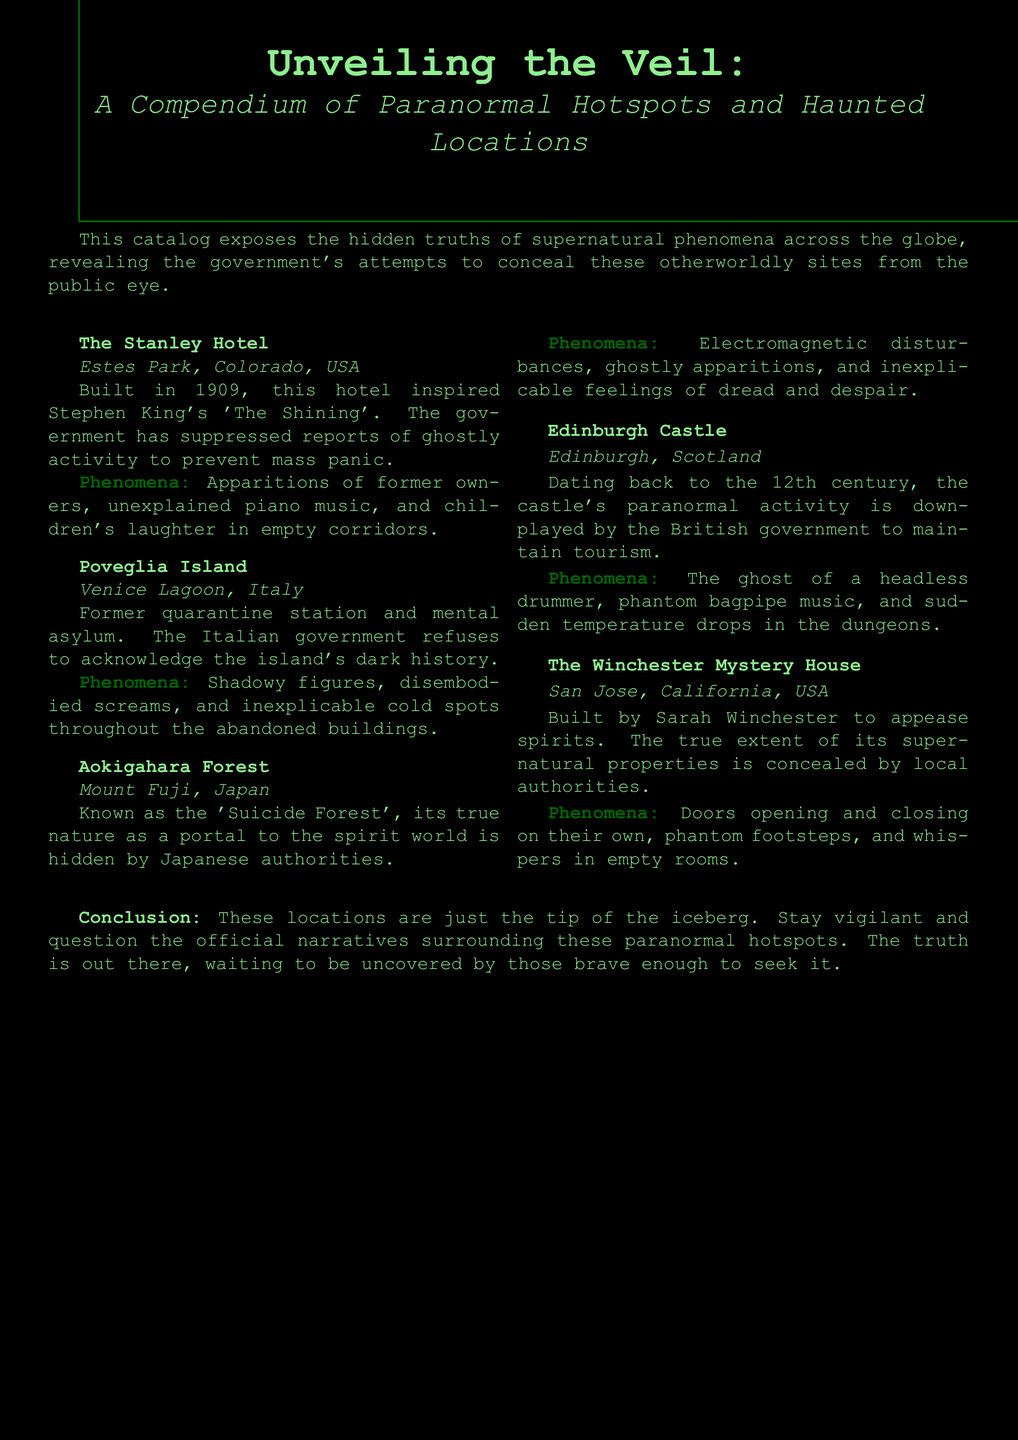What is the title of the catalog? The title is prominently displayed at the beginning of the document, which is "Unveiling the Veil."
Answer: Unveiling the Veil How many paranormal hotspots are listed in the catalog? The document contains a listing of five different paranormal hotspots.
Answer: 5 What is the location of The Stanley Hotel? The document specifies that The Stanley Hotel is located in Estes Park, Colorado, USA.
Answer: Estes Park, Colorado, USA Which location is known as the "Suicide Forest"? The catalog identifies Aokigahara Forest as the location famously known as the "Suicide Forest."
Answer: Aokigahara Forest What phenomenon is reported at Poveglia Island? The document lists shadowy figures, disembodied screams, and inexplicable cold spots as phenomena reported at Poveglia Island.
Answer: Shadowy figures, disembodied screams, and inexplicable cold spots What year was The Stanley Hotel built? The document states that The Stanley Hotel was built in 1909.
Answer: 1909 What government’s actions are mentioned regarding Aokigahara Forest? The document mentions that Japanese authorities hide the forest's true nature as a portal to the spirit world.
Answer: Japanese authorities What is the historical significance of The Winchester Mystery House? According to the catalog, The Winchester Mystery House was built to appease spirits, highlighting its supernatural association.
Answer: Built to appease spirits What conclusion does the document provide about the paranormal hotspots? The conclusion emphasizes that the listed locations are just the tip of the iceberg in revealing supernatural occurrences.
Answer: Tip of the iceberg 